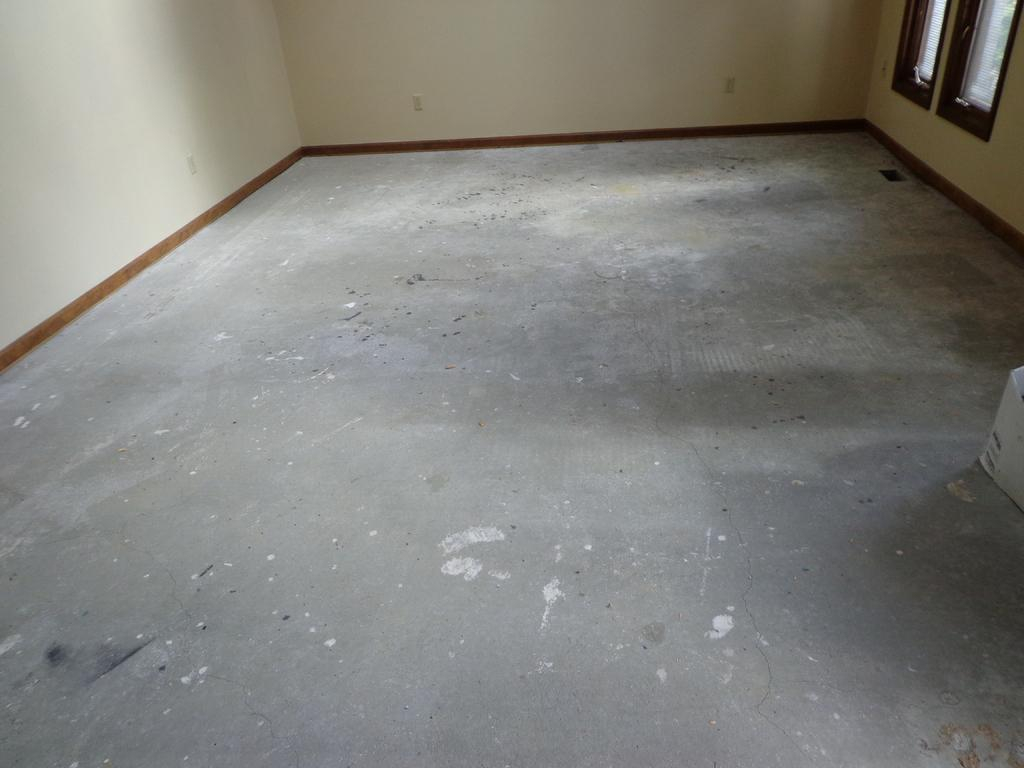What is the main surface visible in the image? There is a floor in the middle of the image. What type of structure can be seen in the background? There is a wall in the background of the image. Where is the window located in the image? The window is in the top right corner of the image. What type of ink can be seen flowing from the boats in the image? There are no boats or ink present in the image. 